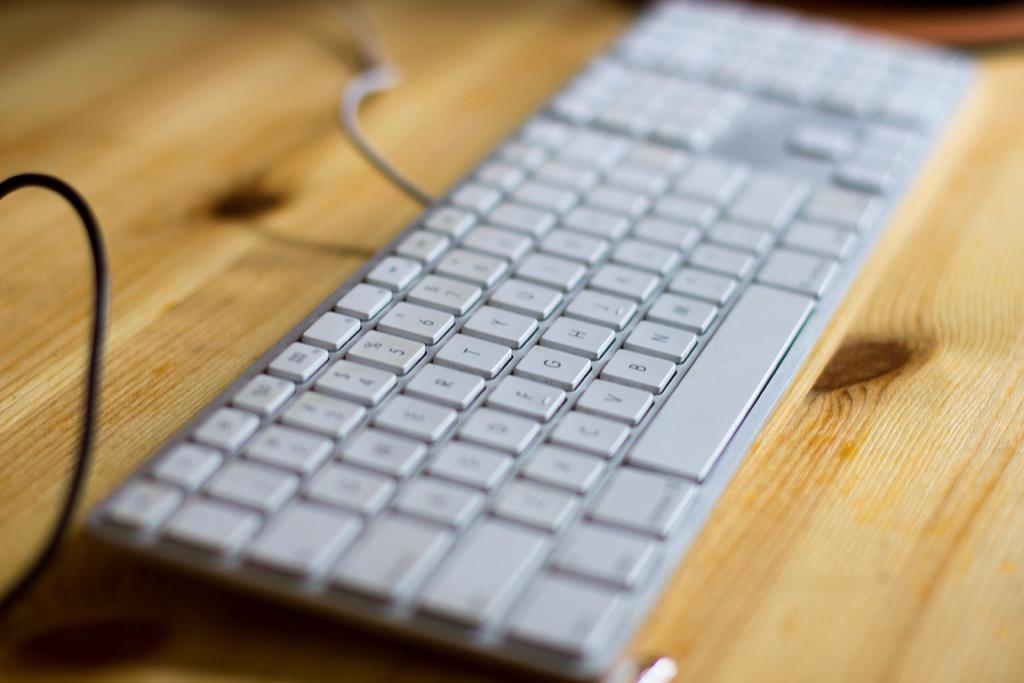<image>
Write a terse but informative summary of the picture. A keyboard is on a table with the letters T, G, H visible. 